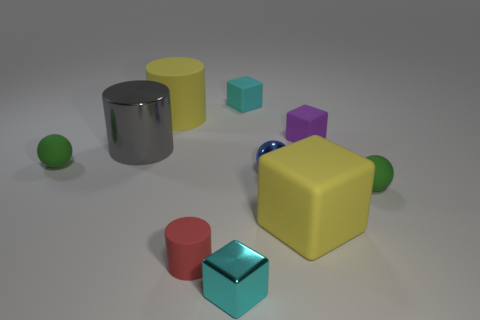How many other objects are the same size as the yellow cube?
Keep it short and to the point. 2. Is the material of the green sphere left of the purple rubber cube the same as the small green object that is right of the cyan shiny object?
Your answer should be very brief. Yes. There is a red rubber cylinder that is in front of the blue ball right of the big gray metallic object; how big is it?
Ensure brevity in your answer.  Small. Are there any large rubber blocks that have the same color as the large matte cylinder?
Offer a terse response. Yes. There is a cube in front of the red rubber cylinder; is its color the same as the tiny rubber object behind the purple object?
Ensure brevity in your answer.  Yes. The red thing has what shape?
Offer a very short reply. Cylinder. There is a cyan metal block; what number of big yellow objects are on the left side of it?
Your response must be concise. 1. What number of green things are the same material as the red object?
Make the answer very short. 2. Is the material of the cube to the right of the yellow rubber block the same as the big cube?
Offer a terse response. Yes. Are there any purple rubber objects?
Offer a very short reply. Yes. 